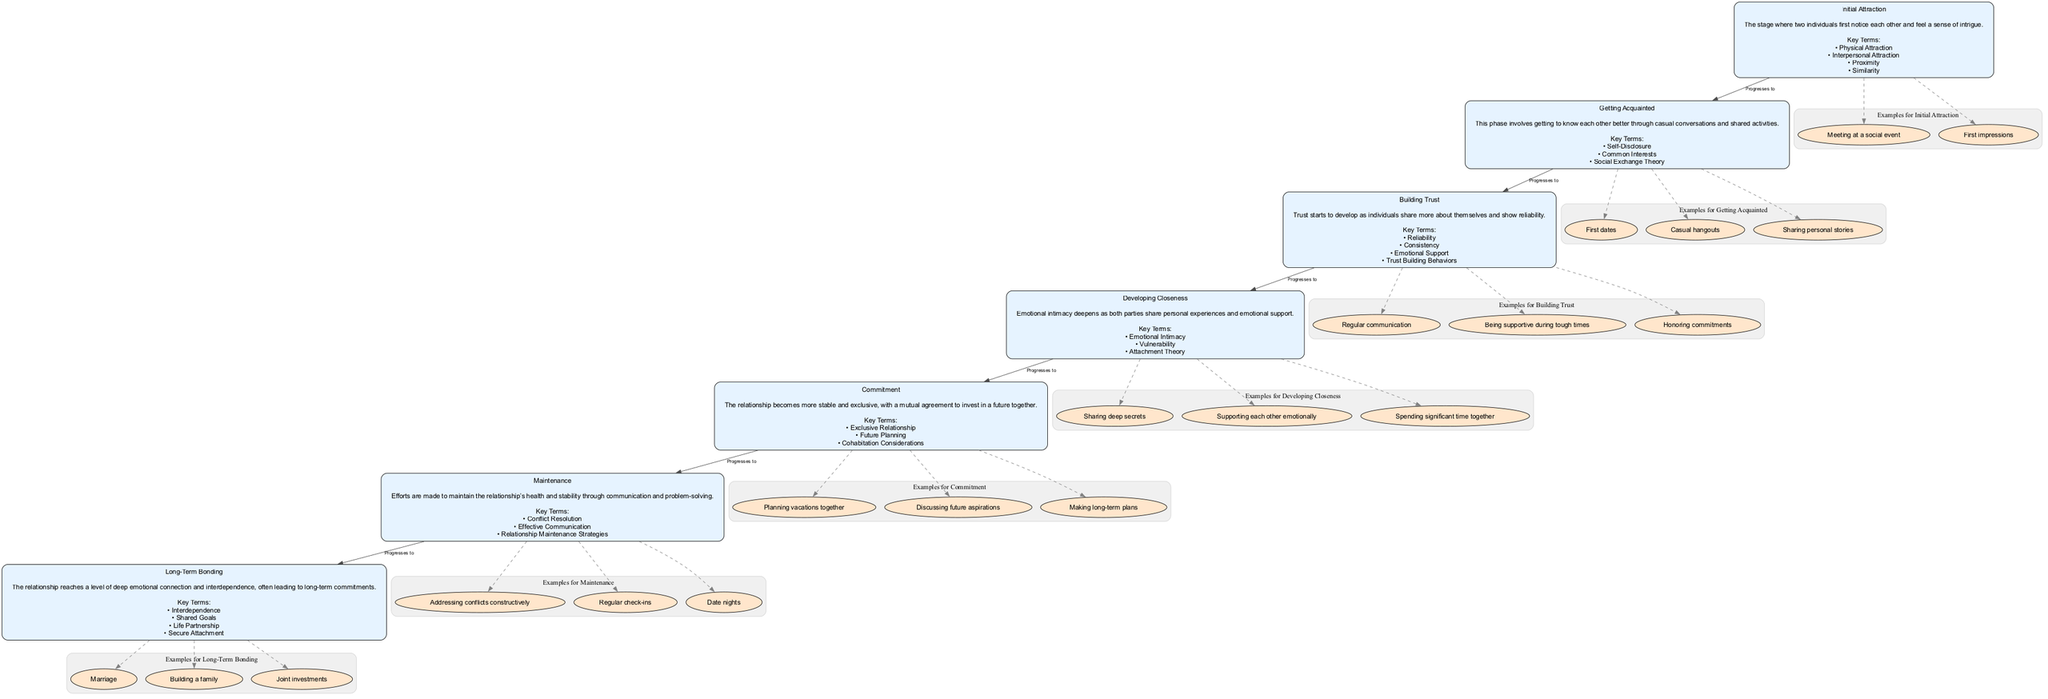What is the first stage of relationship development? The first stage is labeled as "Initial Attraction," which is explicitly stated as the beginning phase in the diagram.
Answer: Initial Attraction How many examples are provided for the "Getting Acquainted" stage? The "Getting Acquainted" stage has three examples listed: first dates, casual hangouts, and sharing personal stories. These can be counted directly in the diagram's examples section.
Answer: 3 What follows "Building Trust" in the stages of relationship development? The stage that follows "Building Trust" is "Developing Closeness," which is indicated by the arrow progression in the diagram showing the flow of relationship stages.
Answer: Developing Closeness What key term is associated with "Commitment"? The key term associated with "Commitment" is "Exclusive Relationship," listed under that stage in the diagram.
Answer: Exclusive Relationship What is the last stage of relationship development? The last stage is labeled as "Long-Term Bonding," which is clearly marked in the progression of the diagram sequences.
Answer: Long-Term Bonding How many key terms are listed under the "Maintenance" stage? There are three key terms listed: Conflict Resolution, Effective Communication, and Relationship Maintenance Strategies, which can be determined by reviewing the key terms section for "Maintenance."
Answer: 3 What stage emphasizes emotional intimacy? The stage that emphasizes emotional intimacy is "Developing Closeness," which is described directly in the stage’s description.
Answer: Developing Closeness Which stage includes examples like "Marriage" and "Building a family"? The examples such as "Marriage" and "Building a family" are linked to the "Long-Term Bonding" stage, as indicated by the example section under that stage.
Answer: Long-Term Bonding What relationship is depicted between "Getting Acquainted" and "Building Trust"? The relationship depicted is that "Getting Acquainted" progresses to "Building Trust," illustrated by the directed edge between the two stages in the diagram.
Answer: Progresses to 